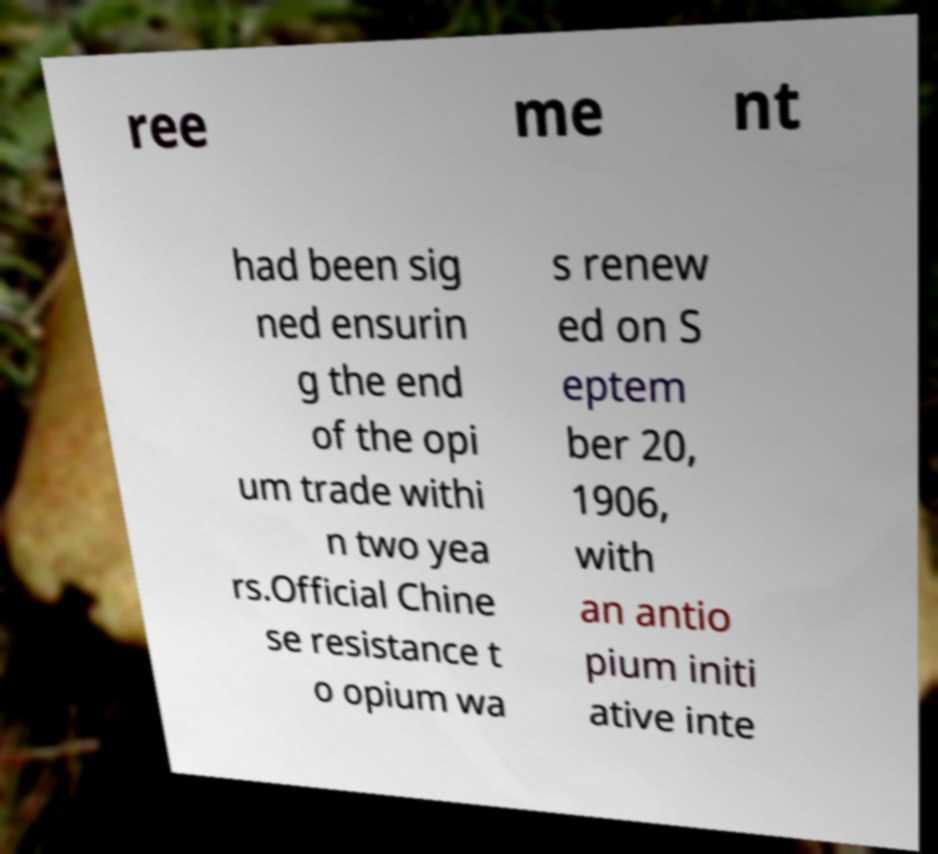Could you extract and type out the text from this image? ree me nt had been sig ned ensurin g the end of the opi um trade withi n two yea rs.Official Chine se resistance t o opium wa s renew ed on S eptem ber 20, 1906, with an antio pium initi ative inte 